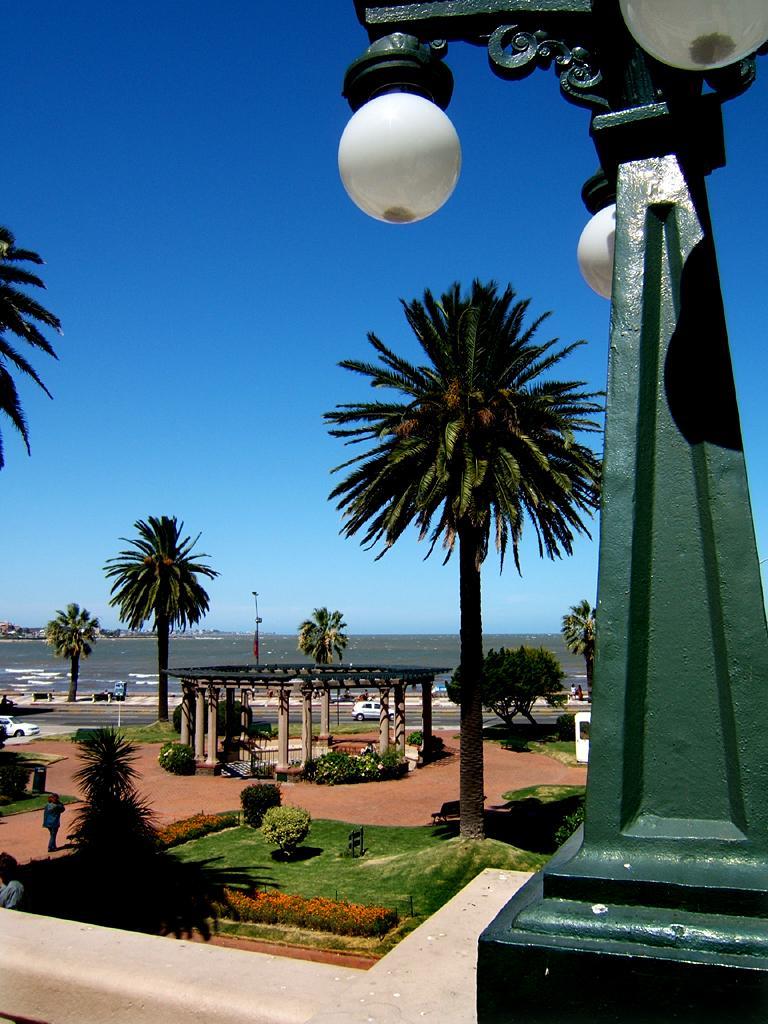Describe this image in one or two sentences. In this picture I can observe some trees on the land. On the right side there is a green color pillar to which some lamps are fixed. In the background there is a sky. 